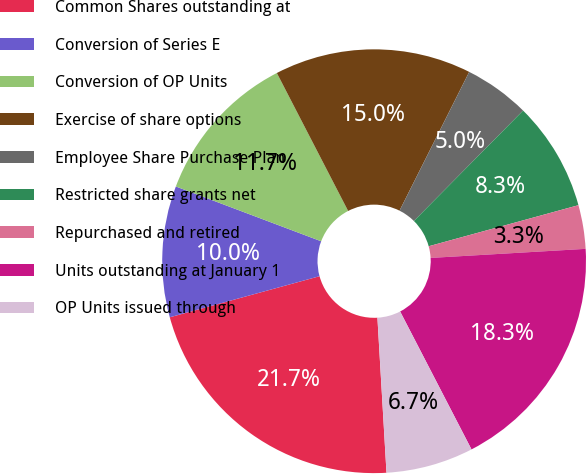Convert chart to OTSL. <chart><loc_0><loc_0><loc_500><loc_500><pie_chart><fcel>Common Shares outstanding at<fcel>Conversion of Series E<fcel>Conversion of OP Units<fcel>Exercise of share options<fcel>Employee Share Purchase Plan<fcel>Restricted share grants net<fcel>Repurchased and retired<fcel>Units outstanding at January 1<fcel>OP Units issued through<nl><fcel>21.67%<fcel>10.0%<fcel>11.67%<fcel>15.0%<fcel>5.0%<fcel>8.33%<fcel>3.33%<fcel>18.33%<fcel>6.67%<nl></chart> 